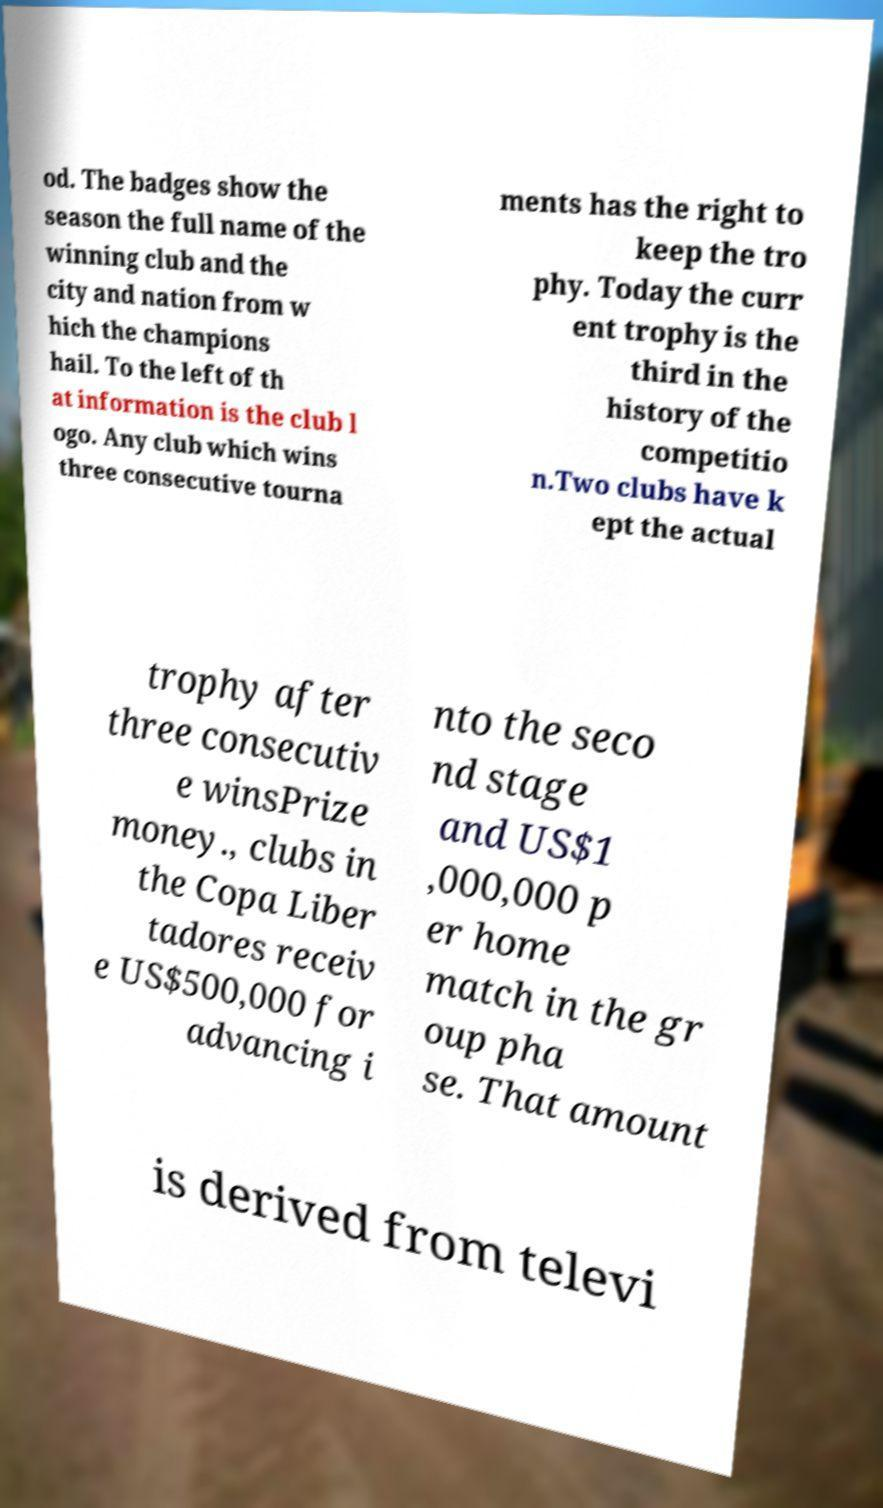What messages or text are displayed in this image? I need them in a readable, typed format. od. The badges show the season the full name of the winning club and the city and nation from w hich the champions hail. To the left of th at information is the club l ogo. Any club which wins three consecutive tourna ments has the right to keep the tro phy. Today the curr ent trophy is the third in the history of the competitio n.Two clubs have k ept the actual trophy after three consecutiv e winsPrize money., clubs in the Copa Liber tadores receiv e US$500,000 for advancing i nto the seco nd stage and US$1 ,000,000 p er home match in the gr oup pha se. That amount is derived from televi 